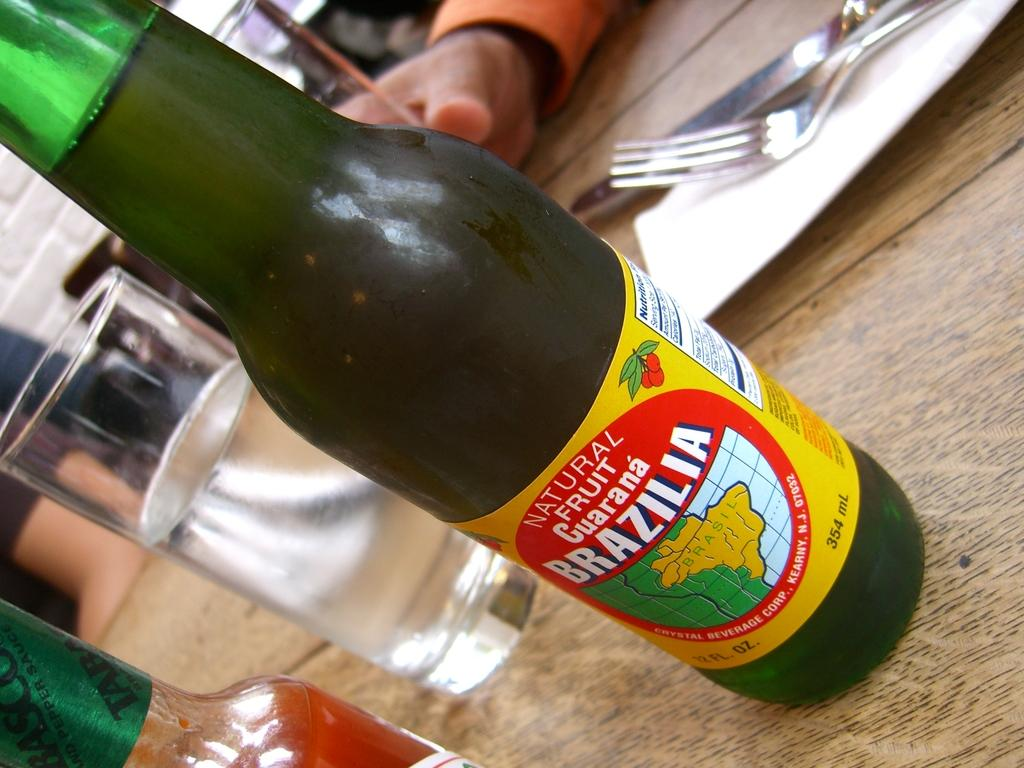<image>
Offer a succinct explanation of the picture presented. A full bottle containing natural fruit guarana called Brazilia 